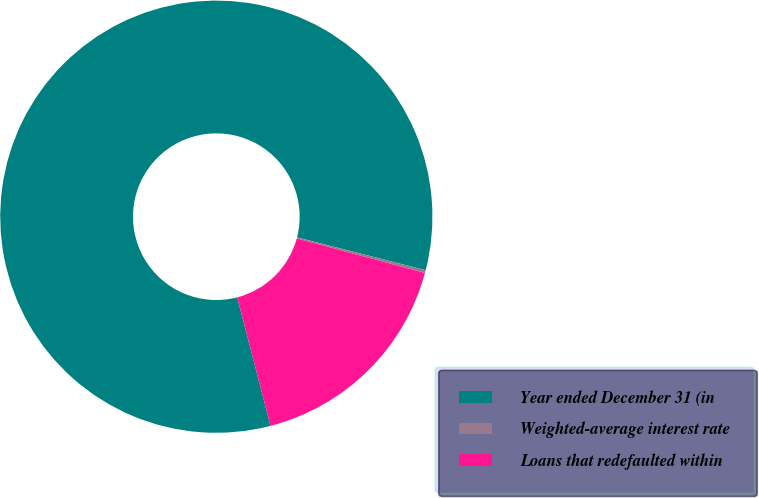Convert chart. <chart><loc_0><loc_0><loc_500><loc_500><pie_chart><fcel>Year ended December 31 (in<fcel>Weighted-average interest rate<fcel>Loans that redefaulted within<nl><fcel>83.02%<fcel>0.21%<fcel>16.77%<nl></chart> 